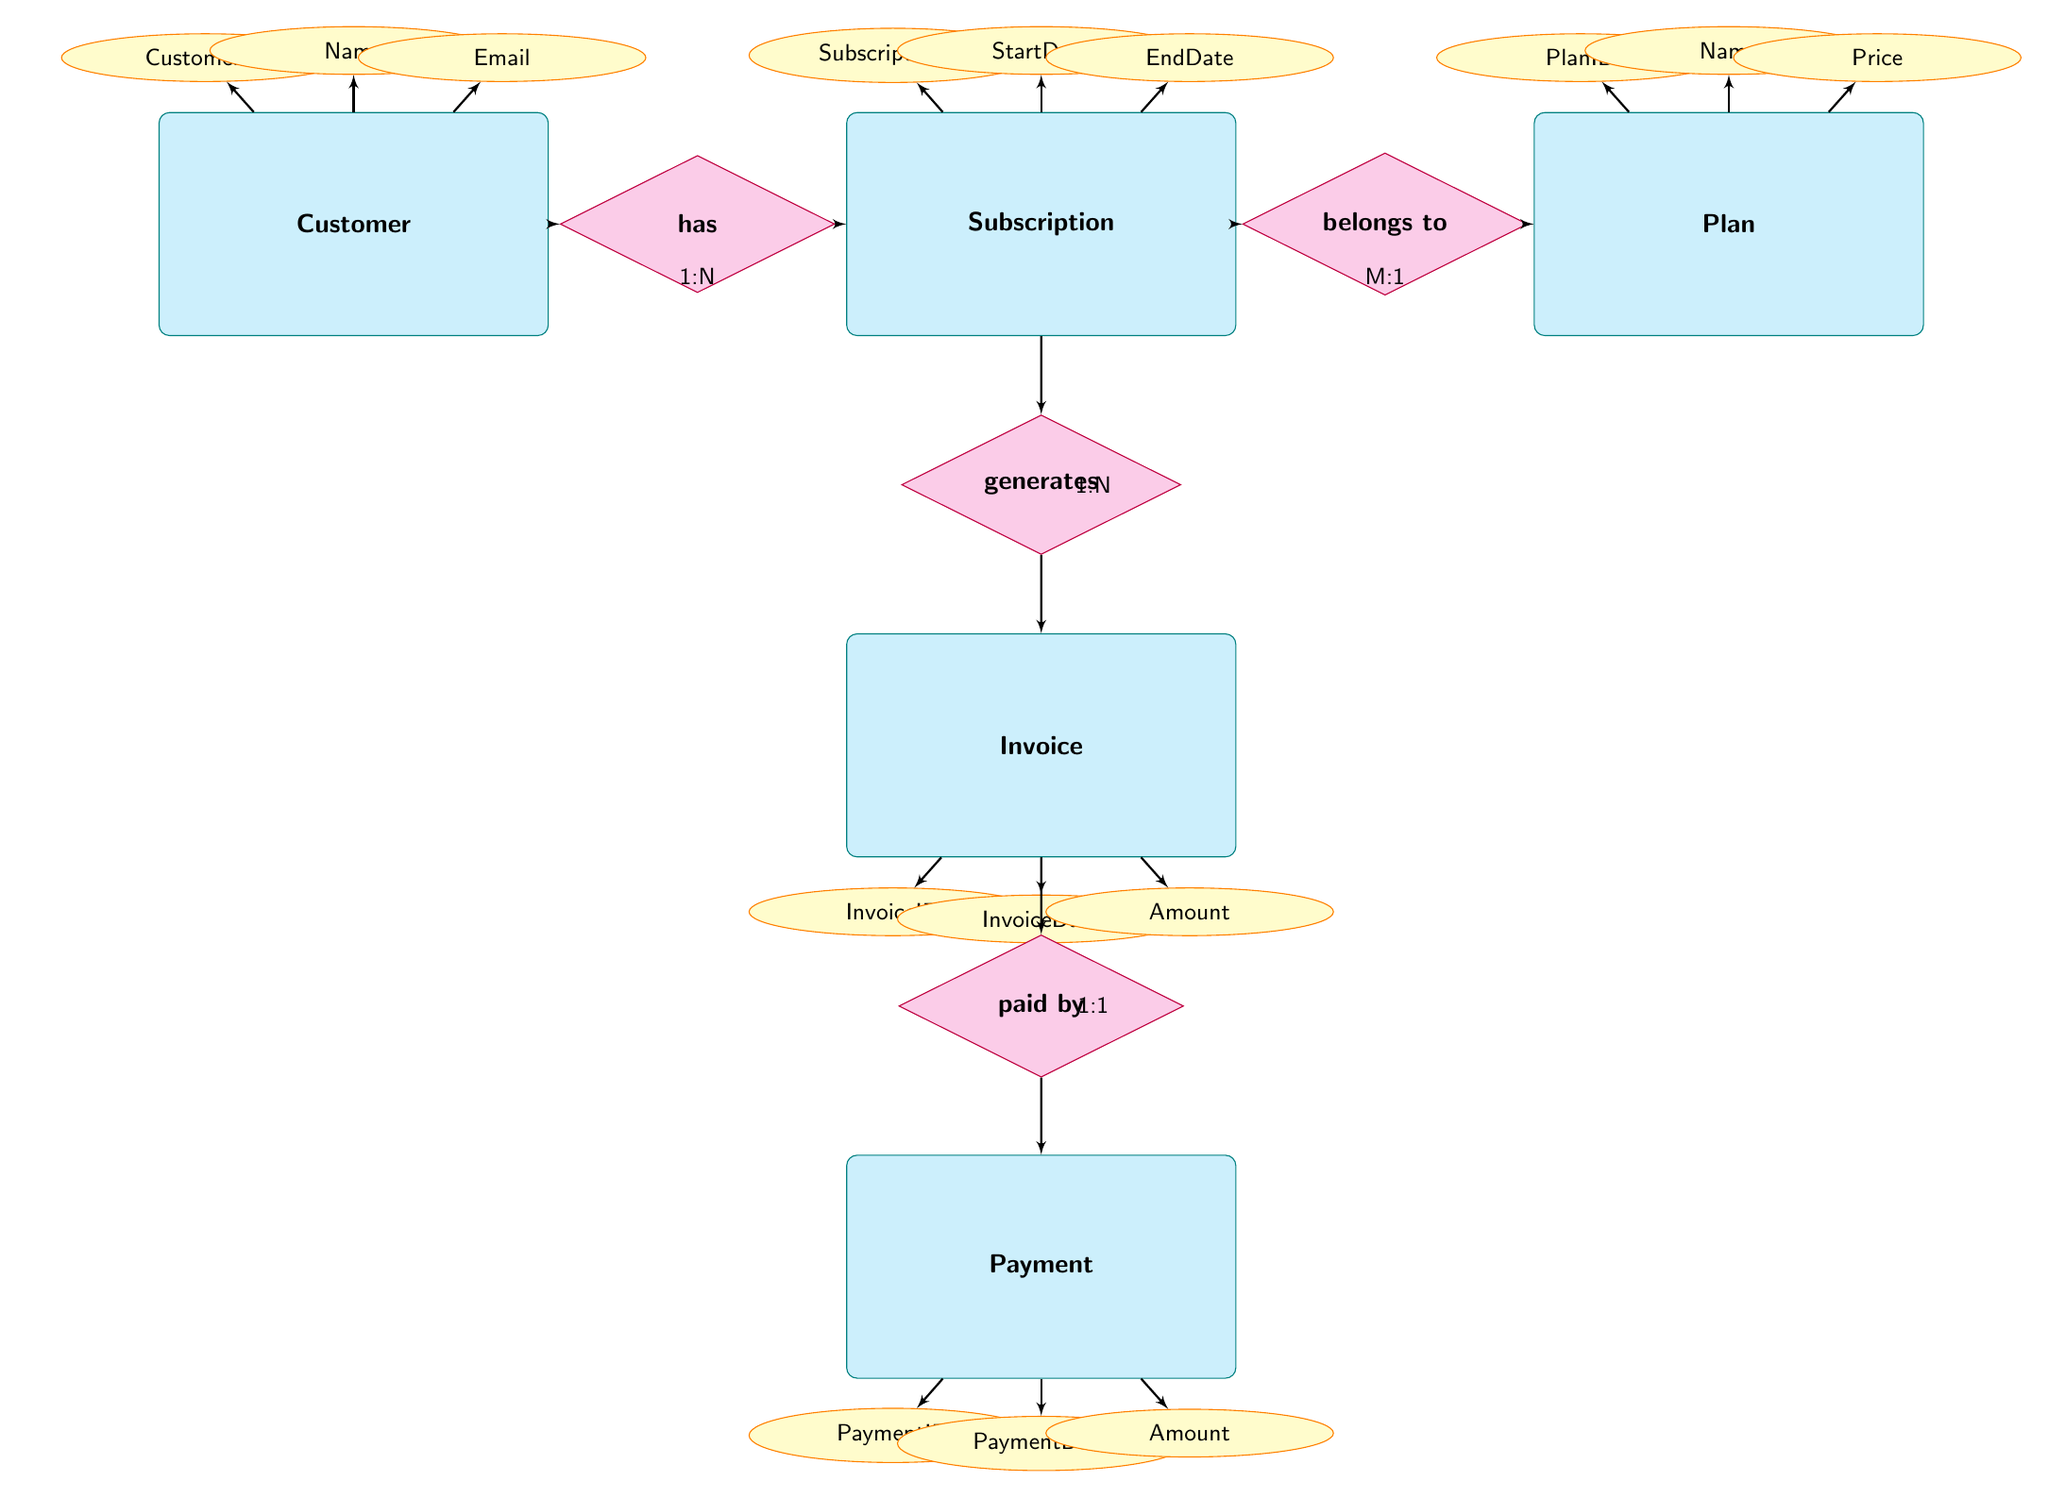What is the primary key for the Customer entity? The primary key is indicated in the diagram. For the Customer entity, it is labeled as "CustomerID".
Answer: CustomerID How many attributes does the Subscription entity have? Looking at the Subscription entity in the diagram, there are three attributes listed: SubscriptionID, StartDate, and EndDate. Therefore, the count is three.
Answer: 3 What relationship exists between Subscription and Plan? The diagram shows that Subscription "belongs to" a Plan, which is represented by the labeled diamond connecting the two entities.
Answer: belongs to How many invoices can a Subscription generate? The relationship between Subscription and Invoice is labeled as "generates" and is represented with a 1:N cardinality, indicating that one Subscription can generate multiple Invoices.
Answer: N What is the cardinality of the relationship between Customer and Subscription? The diagram illustrates that the relationship between Customer and Subscription is labeled as "has" with a 1:N cardinality, meaning one Customer can have multiple Subscriptions.
Answer: 1:N What attribute in the Invoice entity represents the monetary amount? In the Invoice entity, the attribute labeled "Amount" represents the monetary amount associated with each invoice.
Answer: Amount Which entity is directly linked to Payment? According to the diagram, the Payment entity is directly linked to the Invoice entity via the "paid by" relationship.
Answer: Invoice What is the primary key for the Subscription entity? Referring to the diagram, the primary key for the Subscription entity is indicated as "SubscriptionID".
Answer: SubscriptionID Which entities have a one-to-one relationship? The diagram shows that the Invoice and Payment entities have a one-to-one relationship, as denoted by the "paid by" connection with a cardinality of 1:1.
Answer: Invoice and Payment 